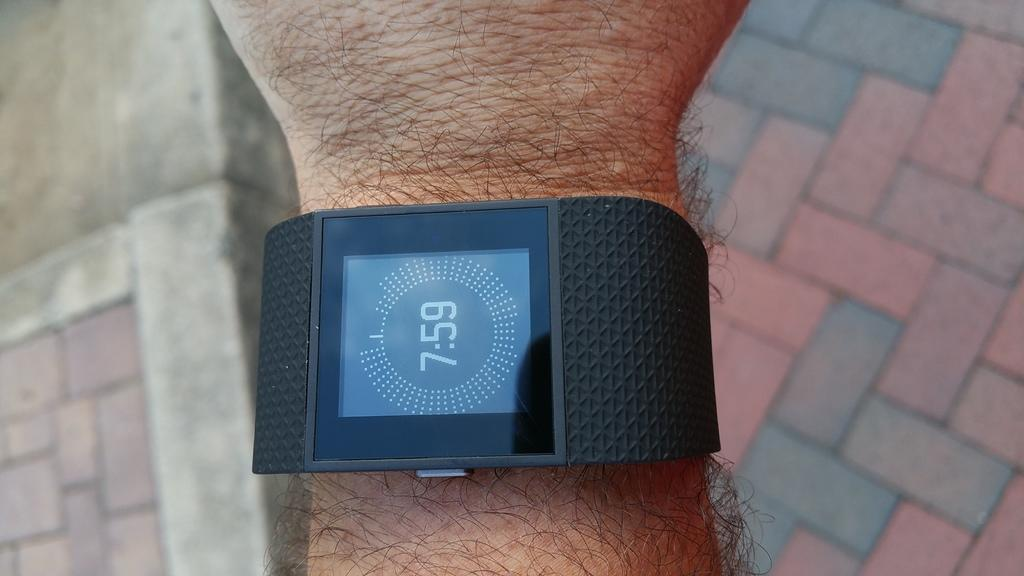<image>
Give a short and clear explanation of the subsequent image. A smart watch on a wrist reads 7:59. 